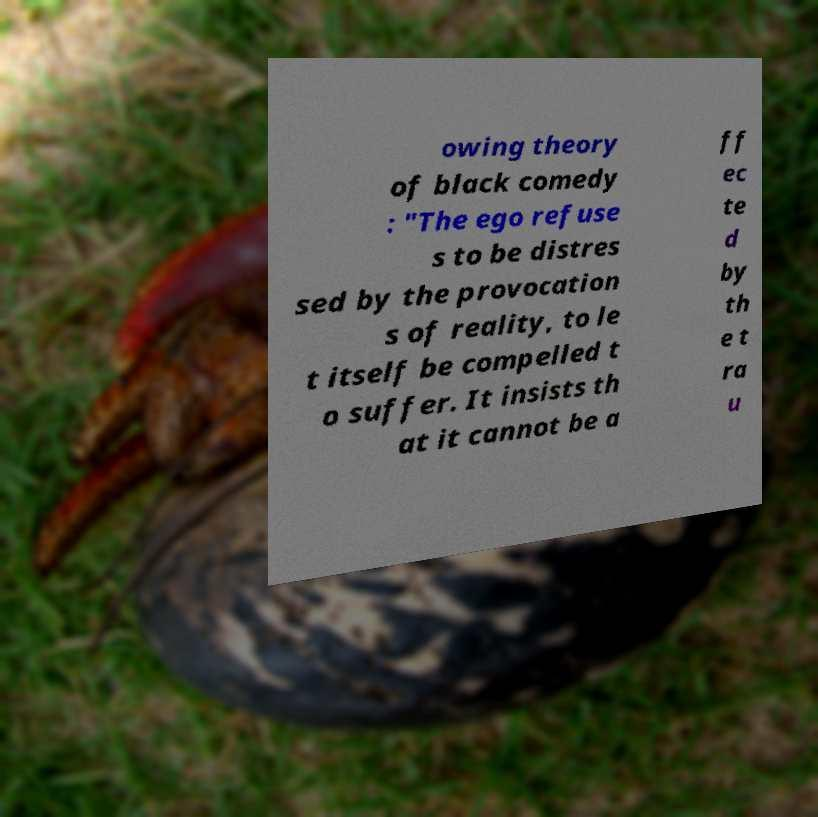Could you extract and type out the text from this image? owing theory of black comedy : "The ego refuse s to be distres sed by the provocation s of reality, to le t itself be compelled t o suffer. It insists th at it cannot be a ff ec te d by th e t ra u 